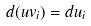<formula> <loc_0><loc_0><loc_500><loc_500>d ( u v _ { i } ) = d u _ { i }</formula> 